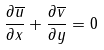Convert formula to latex. <formula><loc_0><loc_0><loc_500><loc_500>\frac { \partial \overline { u } } { \partial x } + \frac { \partial \overline { v } } { \partial y } = 0</formula> 